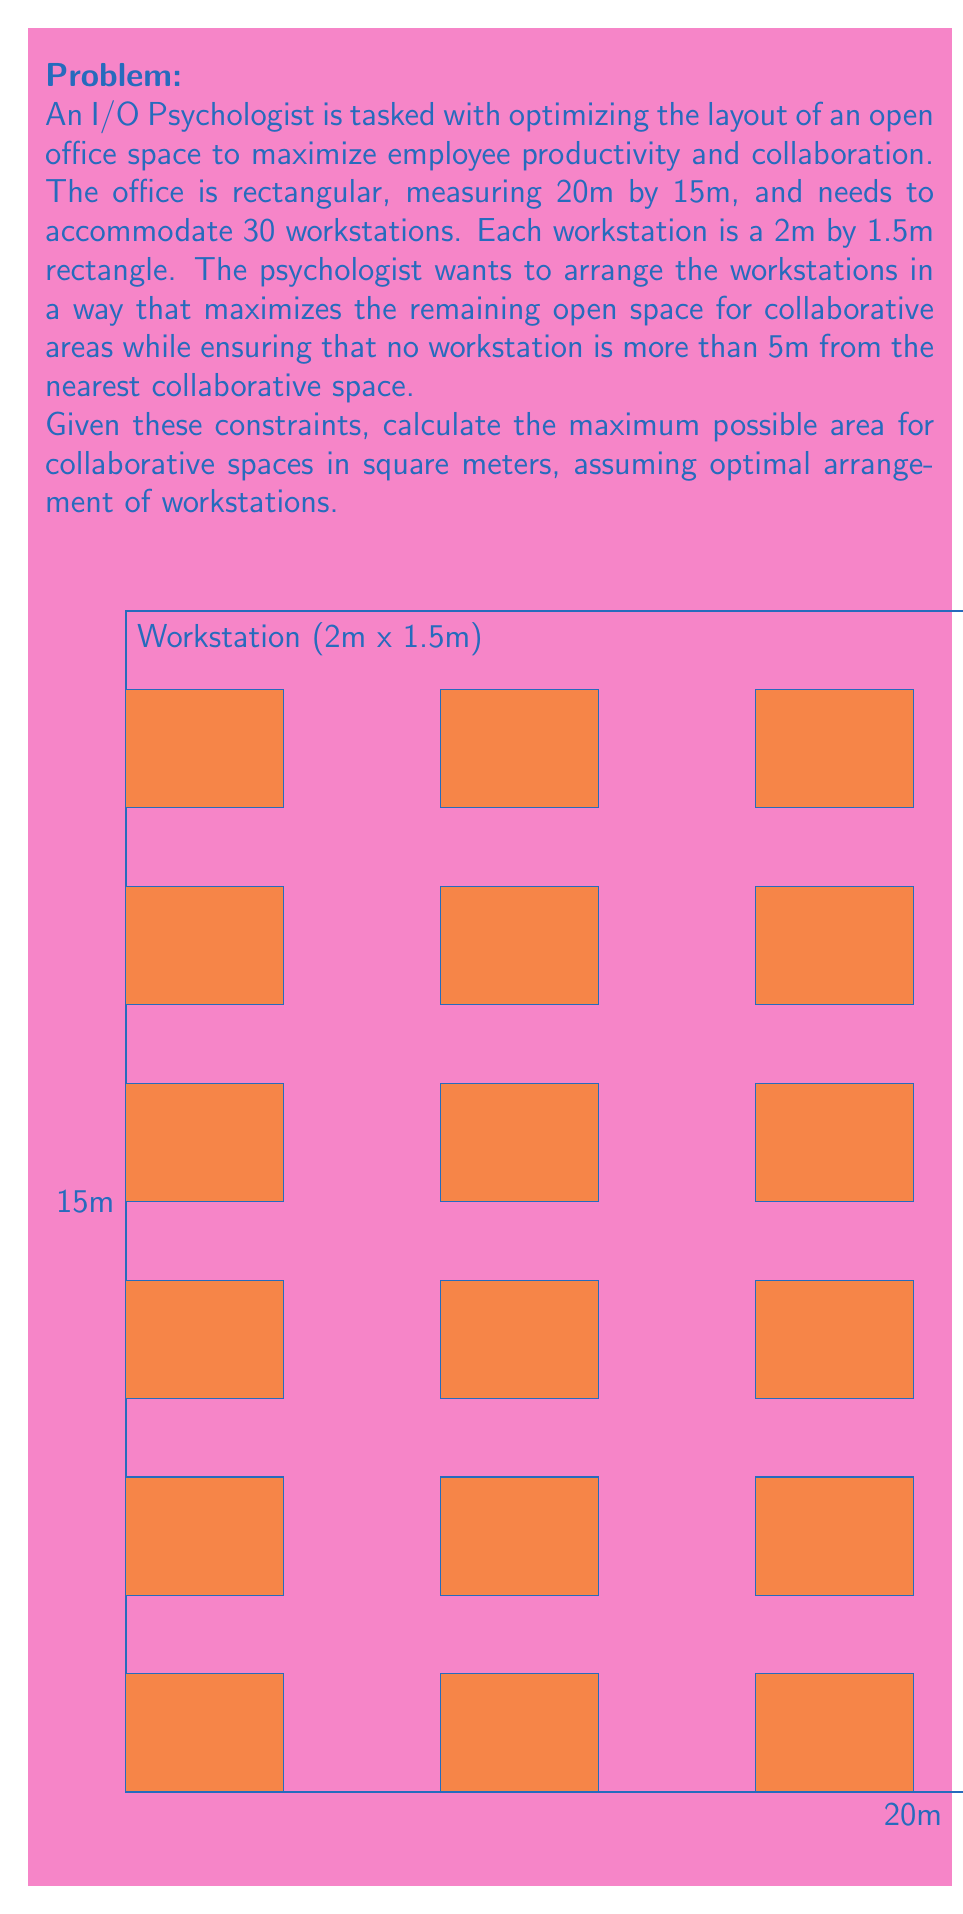Could you help me with this problem? Let's approach this step-by-step:

1) First, calculate the total area of the office:
   $$A_{total} = 20m \times 15m = 300m^2$$

2) Calculate the area of each workstation:
   $$A_{workstation} = 2m \times 1.5m = 3m^2$$

3) Calculate the total area occupied by workstations:
   $$A_{all workstations} = 30 \times 3m^2 = 90m^2$$

4) To maximize collaborative space while ensuring no workstation is more than 5m from a collaborative area, we can arrange the workstations in strips with collaborative spaces between them.

5) The optimal arrangement would be 5 strips of 6 workstations each. This creates 6 rows (including the edges) where collaborative spaces can be placed.

6) Each strip of workstations is 2m wide and 15m long (full length of the office).
   Area of each strip: $$A_{strip} = 2m \times 15m = 30m^2$$

7) Total area of all strips:
   $$A_{all strips} = 5 \times 30m^2 = 150m^2$$

8) The remaining area is for collaborative spaces:
   $$A_{collaborative} = A_{total} - A_{all strips} = 300m^2 - 150m^2 = 150m^2$$

Therefore, the maximum possible area for collaborative spaces is 150m².
Answer: 150m² 